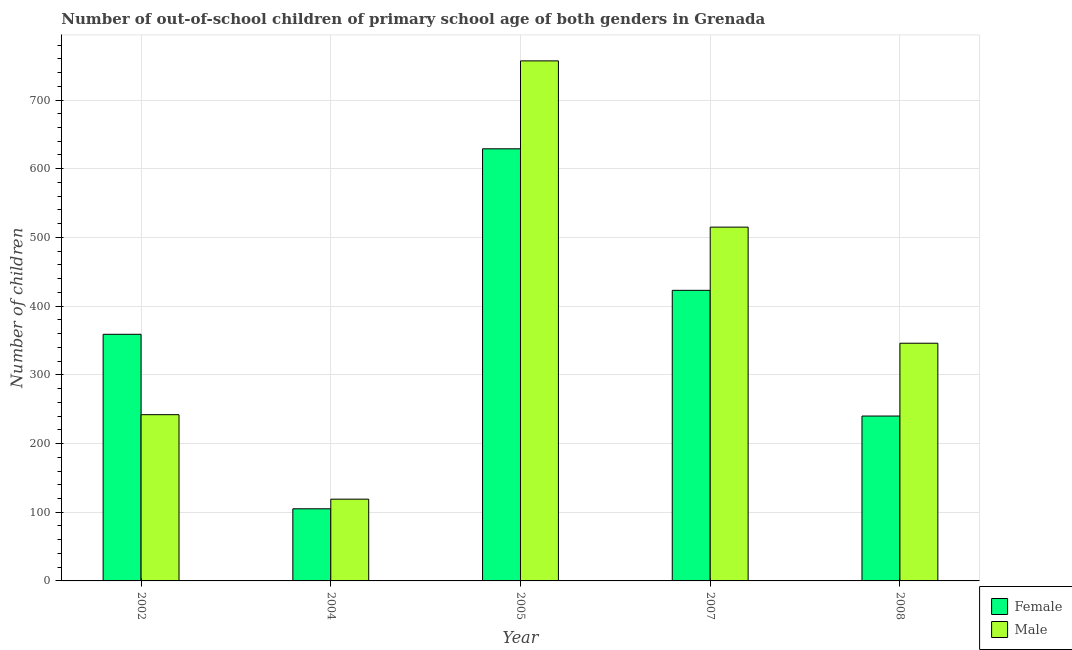How many different coloured bars are there?
Your answer should be very brief. 2. How many groups of bars are there?
Offer a very short reply. 5. Are the number of bars per tick equal to the number of legend labels?
Your response must be concise. Yes. Are the number of bars on each tick of the X-axis equal?
Provide a short and direct response. Yes. How many bars are there on the 4th tick from the left?
Give a very brief answer. 2. How many bars are there on the 4th tick from the right?
Your response must be concise. 2. What is the label of the 4th group of bars from the left?
Give a very brief answer. 2007. What is the number of female out-of-school students in 2002?
Your answer should be very brief. 359. Across all years, what is the maximum number of female out-of-school students?
Provide a short and direct response. 629. Across all years, what is the minimum number of male out-of-school students?
Your answer should be very brief. 119. In which year was the number of female out-of-school students maximum?
Make the answer very short. 2005. In which year was the number of female out-of-school students minimum?
Offer a terse response. 2004. What is the total number of female out-of-school students in the graph?
Your response must be concise. 1756. What is the difference between the number of female out-of-school students in 2005 and that in 2008?
Provide a short and direct response. 389. What is the difference between the number of male out-of-school students in 2004 and the number of female out-of-school students in 2007?
Provide a succinct answer. -396. What is the average number of male out-of-school students per year?
Offer a very short reply. 395.8. In the year 2007, what is the difference between the number of female out-of-school students and number of male out-of-school students?
Your answer should be compact. 0. What is the ratio of the number of male out-of-school students in 2004 to that in 2008?
Keep it short and to the point. 0.34. What is the difference between the highest and the second highest number of male out-of-school students?
Provide a succinct answer. 242. What is the difference between the highest and the lowest number of male out-of-school students?
Provide a succinct answer. 638. What does the 2nd bar from the right in 2008 represents?
Offer a very short reply. Female. Are all the bars in the graph horizontal?
Ensure brevity in your answer.  No. How many years are there in the graph?
Your response must be concise. 5. Does the graph contain any zero values?
Your answer should be very brief. No. Where does the legend appear in the graph?
Your answer should be very brief. Bottom right. How are the legend labels stacked?
Offer a very short reply. Vertical. What is the title of the graph?
Provide a succinct answer. Number of out-of-school children of primary school age of both genders in Grenada. What is the label or title of the X-axis?
Give a very brief answer. Year. What is the label or title of the Y-axis?
Make the answer very short. Number of children. What is the Number of children of Female in 2002?
Your response must be concise. 359. What is the Number of children of Male in 2002?
Make the answer very short. 242. What is the Number of children of Female in 2004?
Your response must be concise. 105. What is the Number of children of Male in 2004?
Offer a very short reply. 119. What is the Number of children in Female in 2005?
Your response must be concise. 629. What is the Number of children of Male in 2005?
Keep it short and to the point. 757. What is the Number of children in Female in 2007?
Keep it short and to the point. 423. What is the Number of children in Male in 2007?
Your response must be concise. 515. What is the Number of children of Female in 2008?
Provide a succinct answer. 240. What is the Number of children of Male in 2008?
Offer a very short reply. 346. Across all years, what is the maximum Number of children in Female?
Provide a short and direct response. 629. Across all years, what is the maximum Number of children in Male?
Your answer should be very brief. 757. Across all years, what is the minimum Number of children in Female?
Make the answer very short. 105. Across all years, what is the minimum Number of children of Male?
Make the answer very short. 119. What is the total Number of children in Female in the graph?
Give a very brief answer. 1756. What is the total Number of children of Male in the graph?
Provide a succinct answer. 1979. What is the difference between the Number of children in Female in 2002 and that in 2004?
Your answer should be very brief. 254. What is the difference between the Number of children of Male in 2002 and that in 2004?
Provide a short and direct response. 123. What is the difference between the Number of children of Female in 2002 and that in 2005?
Provide a short and direct response. -270. What is the difference between the Number of children in Male in 2002 and that in 2005?
Ensure brevity in your answer.  -515. What is the difference between the Number of children in Female in 2002 and that in 2007?
Make the answer very short. -64. What is the difference between the Number of children in Male in 2002 and that in 2007?
Your answer should be very brief. -273. What is the difference between the Number of children of Female in 2002 and that in 2008?
Give a very brief answer. 119. What is the difference between the Number of children in Male in 2002 and that in 2008?
Provide a succinct answer. -104. What is the difference between the Number of children in Female in 2004 and that in 2005?
Keep it short and to the point. -524. What is the difference between the Number of children in Male in 2004 and that in 2005?
Your response must be concise. -638. What is the difference between the Number of children of Female in 2004 and that in 2007?
Keep it short and to the point. -318. What is the difference between the Number of children in Male in 2004 and that in 2007?
Offer a very short reply. -396. What is the difference between the Number of children of Female in 2004 and that in 2008?
Offer a terse response. -135. What is the difference between the Number of children in Male in 2004 and that in 2008?
Offer a very short reply. -227. What is the difference between the Number of children in Female in 2005 and that in 2007?
Offer a very short reply. 206. What is the difference between the Number of children in Male in 2005 and that in 2007?
Offer a terse response. 242. What is the difference between the Number of children in Female in 2005 and that in 2008?
Provide a short and direct response. 389. What is the difference between the Number of children in Male in 2005 and that in 2008?
Provide a short and direct response. 411. What is the difference between the Number of children in Female in 2007 and that in 2008?
Give a very brief answer. 183. What is the difference between the Number of children in Male in 2007 and that in 2008?
Ensure brevity in your answer.  169. What is the difference between the Number of children in Female in 2002 and the Number of children in Male in 2004?
Make the answer very short. 240. What is the difference between the Number of children in Female in 2002 and the Number of children in Male in 2005?
Your answer should be compact. -398. What is the difference between the Number of children in Female in 2002 and the Number of children in Male in 2007?
Keep it short and to the point. -156. What is the difference between the Number of children of Female in 2002 and the Number of children of Male in 2008?
Offer a terse response. 13. What is the difference between the Number of children in Female in 2004 and the Number of children in Male in 2005?
Your answer should be compact. -652. What is the difference between the Number of children of Female in 2004 and the Number of children of Male in 2007?
Offer a very short reply. -410. What is the difference between the Number of children in Female in 2004 and the Number of children in Male in 2008?
Offer a terse response. -241. What is the difference between the Number of children in Female in 2005 and the Number of children in Male in 2007?
Offer a very short reply. 114. What is the difference between the Number of children of Female in 2005 and the Number of children of Male in 2008?
Offer a terse response. 283. What is the average Number of children in Female per year?
Offer a terse response. 351.2. What is the average Number of children in Male per year?
Your response must be concise. 395.8. In the year 2002, what is the difference between the Number of children of Female and Number of children of Male?
Provide a succinct answer. 117. In the year 2005, what is the difference between the Number of children in Female and Number of children in Male?
Offer a very short reply. -128. In the year 2007, what is the difference between the Number of children in Female and Number of children in Male?
Your response must be concise. -92. In the year 2008, what is the difference between the Number of children in Female and Number of children in Male?
Provide a succinct answer. -106. What is the ratio of the Number of children in Female in 2002 to that in 2004?
Your answer should be very brief. 3.42. What is the ratio of the Number of children of Male in 2002 to that in 2004?
Offer a terse response. 2.03. What is the ratio of the Number of children in Female in 2002 to that in 2005?
Keep it short and to the point. 0.57. What is the ratio of the Number of children in Male in 2002 to that in 2005?
Offer a very short reply. 0.32. What is the ratio of the Number of children of Female in 2002 to that in 2007?
Your answer should be very brief. 0.85. What is the ratio of the Number of children of Male in 2002 to that in 2007?
Provide a succinct answer. 0.47. What is the ratio of the Number of children in Female in 2002 to that in 2008?
Give a very brief answer. 1.5. What is the ratio of the Number of children in Male in 2002 to that in 2008?
Ensure brevity in your answer.  0.7. What is the ratio of the Number of children in Female in 2004 to that in 2005?
Make the answer very short. 0.17. What is the ratio of the Number of children in Male in 2004 to that in 2005?
Offer a terse response. 0.16. What is the ratio of the Number of children of Female in 2004 to that in 2007?
Provide a succinct answer. 0.25. What is the ratio of the Number of children in Male in 2004 to that in 2007?
Keep it short and to the point. 0.23. What is the ratio of the Number of children of Female in 2004 to that in 2008?
Your answer should be compact. 0.44. What is the ratio of the Number of children in Male in 2004 to that in 2008?
Your answer should be very brief. 0.34. What is the ratio of the Number of children of Female in 2005 to that in 2007?
Your response must be concise. 1.49. What is the ratio of the Number of children of Male in 2005 to that in 2007?
Your response must be concise. 1.47. What is the ratio of the Number of children of Female in 2005 to that in 2008?
Your answer should be very brief. 2.62. What is the ratio of the Number of children of Male in 2005 to that in 2008?
Provide a short and direct response. 2.19. What is the ratio of the Number of children in Female in 2007 to that in 2008?
Ensure brevity in your answer.  1.76. What is the ratio of the Number of children of Male in 2007 to that in 2008?
Give a very brief answer. 1.49. What is the difference between the highest and the second highest Number of children of Female?
Keep it short and to the point. 206. What is the difference between the highest and the second highest Number of children in Male?
Your response must be concise. 242. What is the difference between the highest and the lowest Number of children in Female?
Give a very brief answer. 524. What is the difference between the highest and the lowest Number of children of Male?
Provide a succinct answer. 638. 